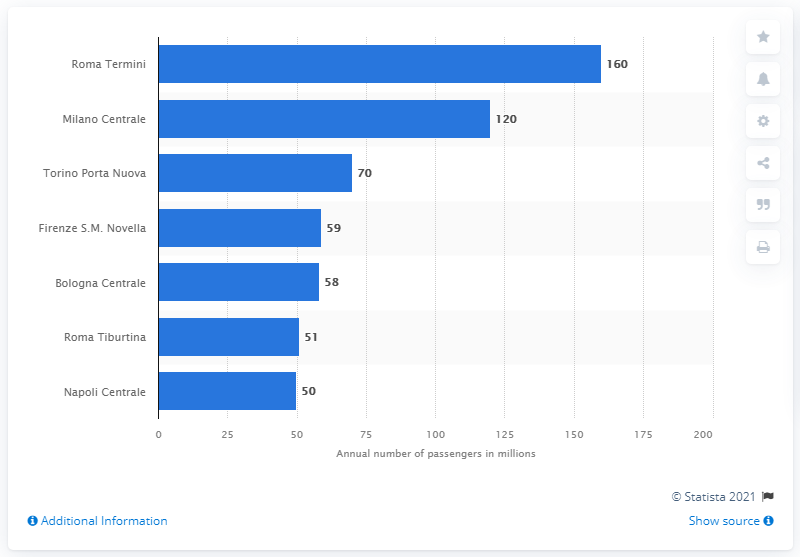Point out several critical features in this image. As of 2020, Roma Termini was the train station with the highest annual number of passengers. 